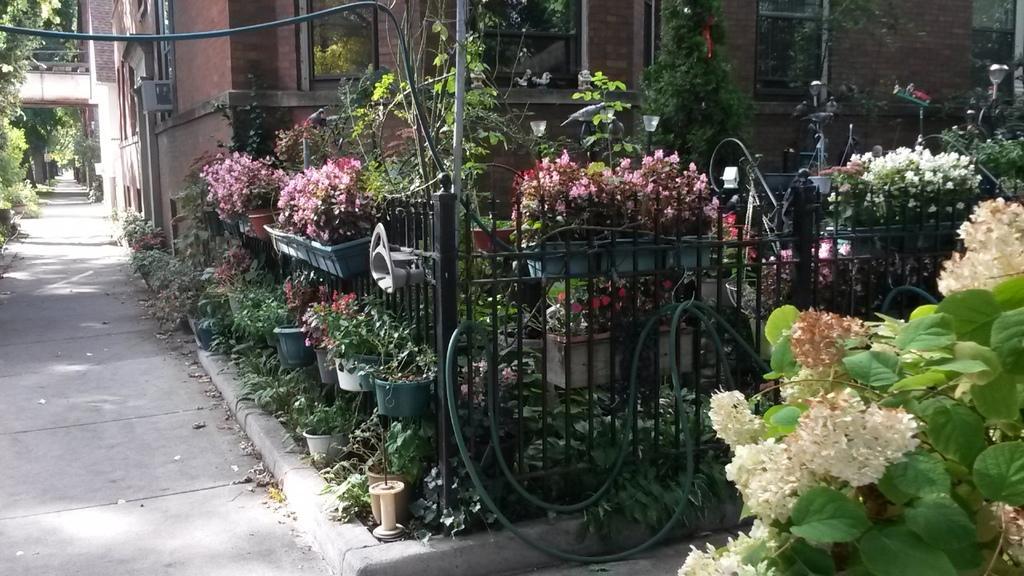Can you describe this image briefly? In this image I can see the road, the railing, few flower pots with trees and flowers which are pink in color in them, a tree which is green in color and few flowers which are white in color, few pipes, a building which is brown in color and few windows of the building. 